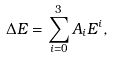<formula> <loc_0><loc_0><loc_500><loc_500>\Delta E = \sum _ { i = 0 } ^ { 3 } A _ { i } E ^ { i } ,</formula> 